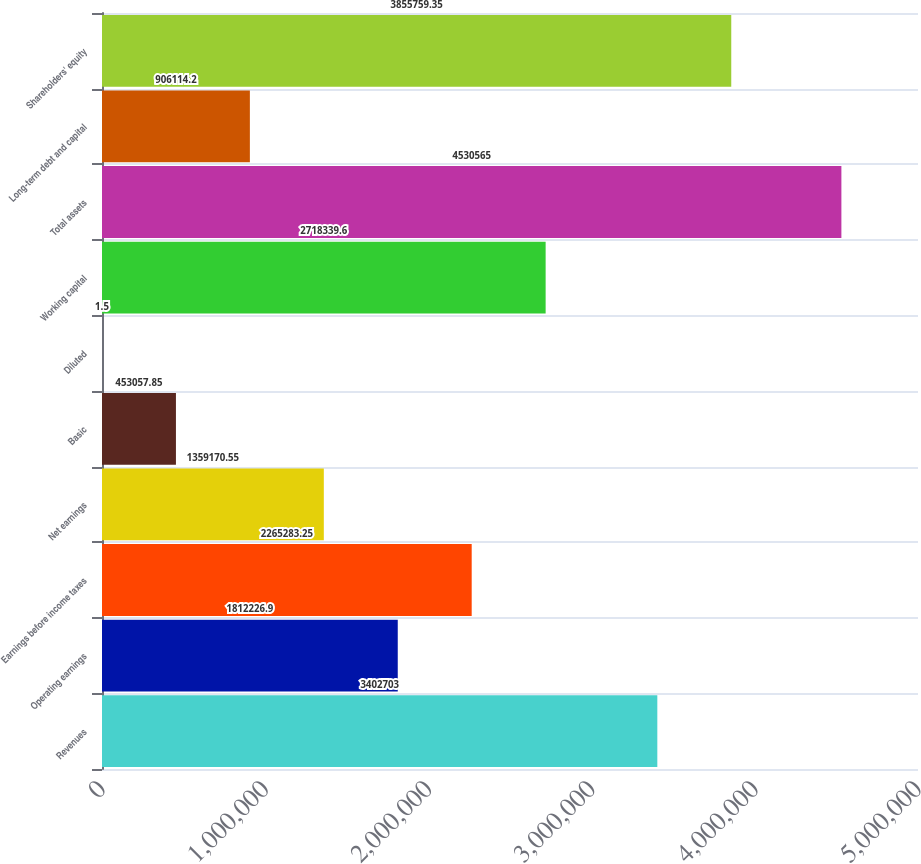<chart> <loc_0><loc_0><loc_500><loc_500><bar_chart><fcel>Revenues<fcel>Operating earnings<fcel>Earnings before income taxes<fcel>Net earnings<fcel>Basic<fcel>Diluted<fcel>Working capital<fcel>Total assets<fcel>Long-term debt and capital<fcel>Shareholders' equity<nl><fcel>3.4027e+06<fcel>1.81223e+06<fcel>2.26528e+06<fcel>1.35917e+06<fcel>453058<fcel>1.5<fcel>2.71834e+06<fcel>4.53056e+06<fcel>906114<fcel>3.85576e+06<nl></chart> 